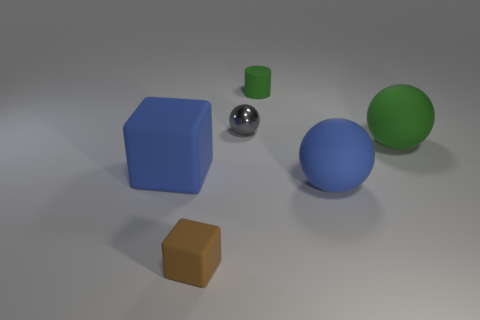Subtract all blue cubes. Subtract all green balls. How many cubes are left? 1 Add 1 big green things. How many objects exist? 7 Subtract all cubes. How many objects are left? 4 Subtract 0 green cubes. How many objects are left? 6 Subtract all big yellow rubber cylinders. Subtract all small brown matte objects. How many objects are left? 5 Add 1 green objects. How many green objects are left? 3 Add 4 big green rubber objects. How many big green rubber objects exist? 5 